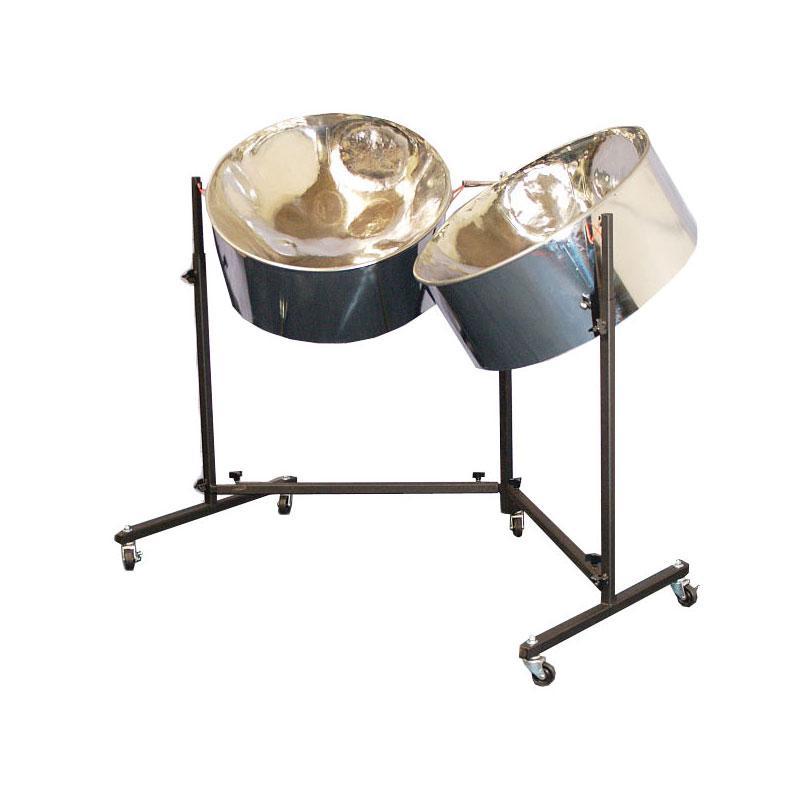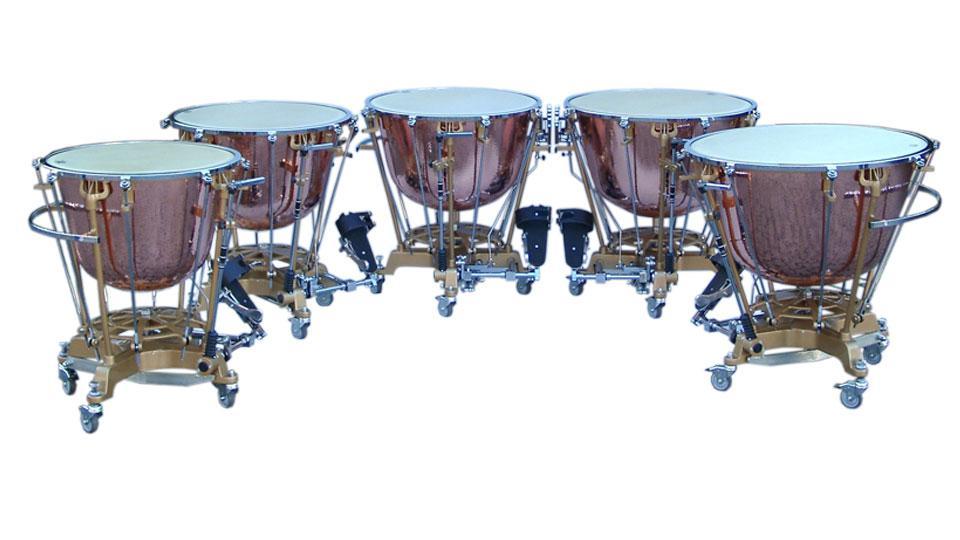The first image is the image on the left, the second image is the image on the right. Analyze the images presented: Is the assertion "Each image features a drum style with a concave top mounted on a pivoting stand, but one image contains one fewer bowl drum than the other image." valid? Answer yes or no. No. The first image is the image on the left, the second image is the image on the right. For the images shown, is this caption "There are 7 drums total." true? Answer yes or no. Yes. 